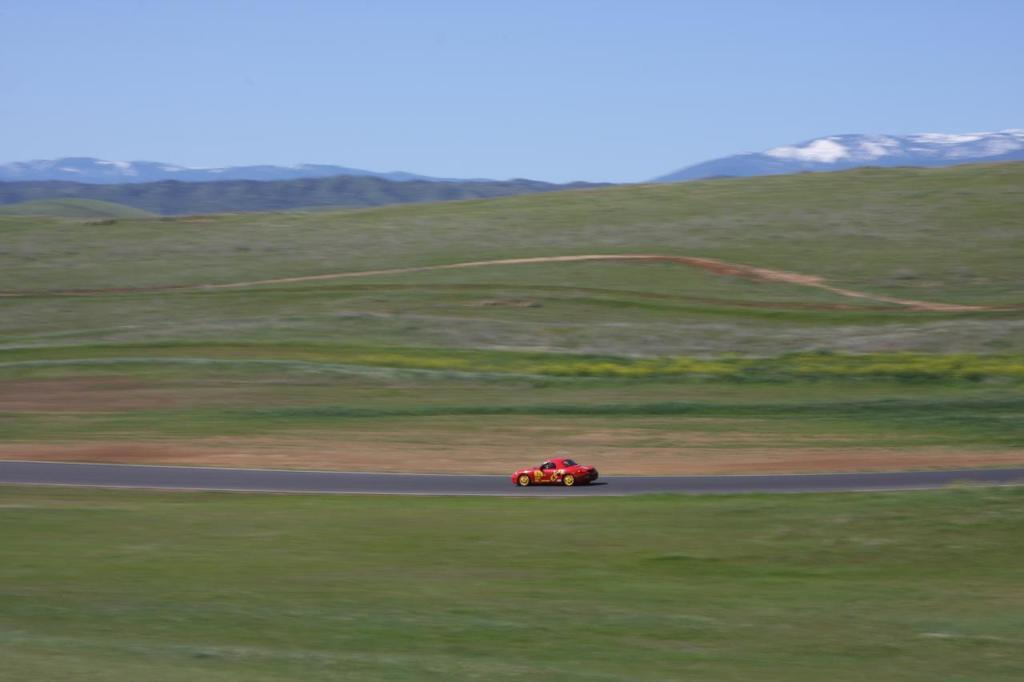What color is the car in the image? The car in the image is red. Where is the car located in the image? The car is on the road in the image. What can be seen on the ground in the image? The ground is visible in the image, and there is grass present. What type of landscape feature is visible in the distance? There are mountains in the image. What is visible at the top of the image? The sky is visible at the top of the image. Can you tell me what type of guitar the manager is playing in the image? There is no guitar or manager present in the image; it features a red car on the road with a grassy ground, mountains in the distance, and a visible sky. 